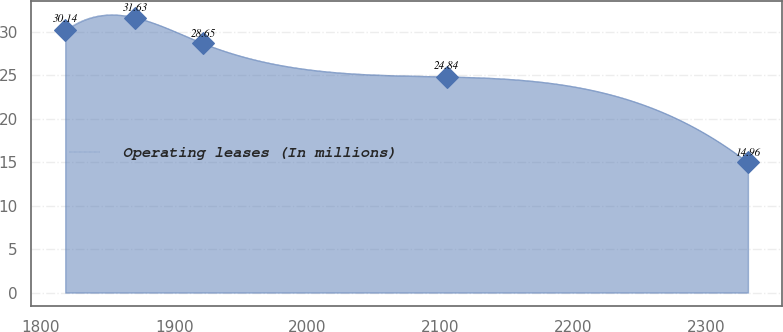Convert chart to OTSL. <chart><loc_0><loc_0><loc_500><loc_500><line_chart><ecel><fcel>Operating leases (In millions)<nl><fcel>1818.21<fcel>30.14<nl><fcel>1870.71<fcel>31.63<nl><fcel>1921.99<fcel>28.65<nl><fcel>2104.84<fcel>24.84<nl><fcel>2331<fcel>14.96<nl></chart> 